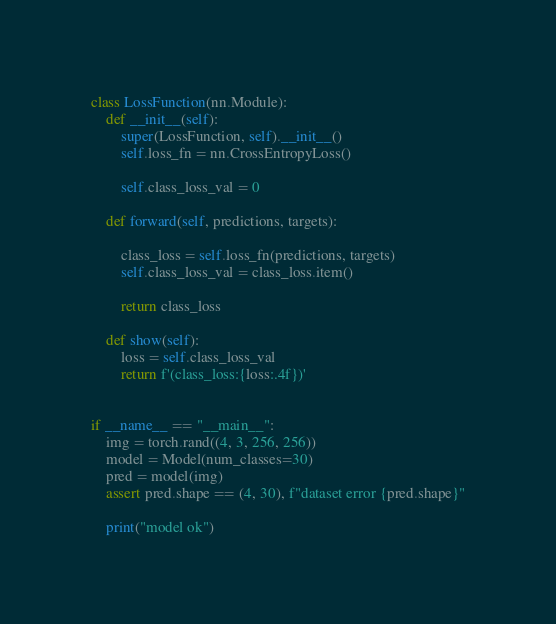Convert code to text. <code><loc_0><loc_0><loc_500><loc_500><_Python_>class LossFunction(nn.Module):
    def __init__(self):
        super(LossFunction, self).__init__()
        self.loss_fn = nn.CrossEntropyLoss()

        self.class_loss_val = 0

    def forward(self, predictions, targets):

        class_loss = self.loss_fn(predictions, targets)
        self.class_loss_val = class_loss.item()

        return class_loss

    def show(self):
        loss = self.class_loss_val
        return f'(class_loss:{loss:.4f})'


if __name__ == "__main__":
    img = torch.rand((4, 3, 256, 256))
    model = Model(num_classes=30)
    pred = model(img)
    assert pred.shape == (4, 30), f"dataset error {pred.shape}"

    print("model ok")
</code> 